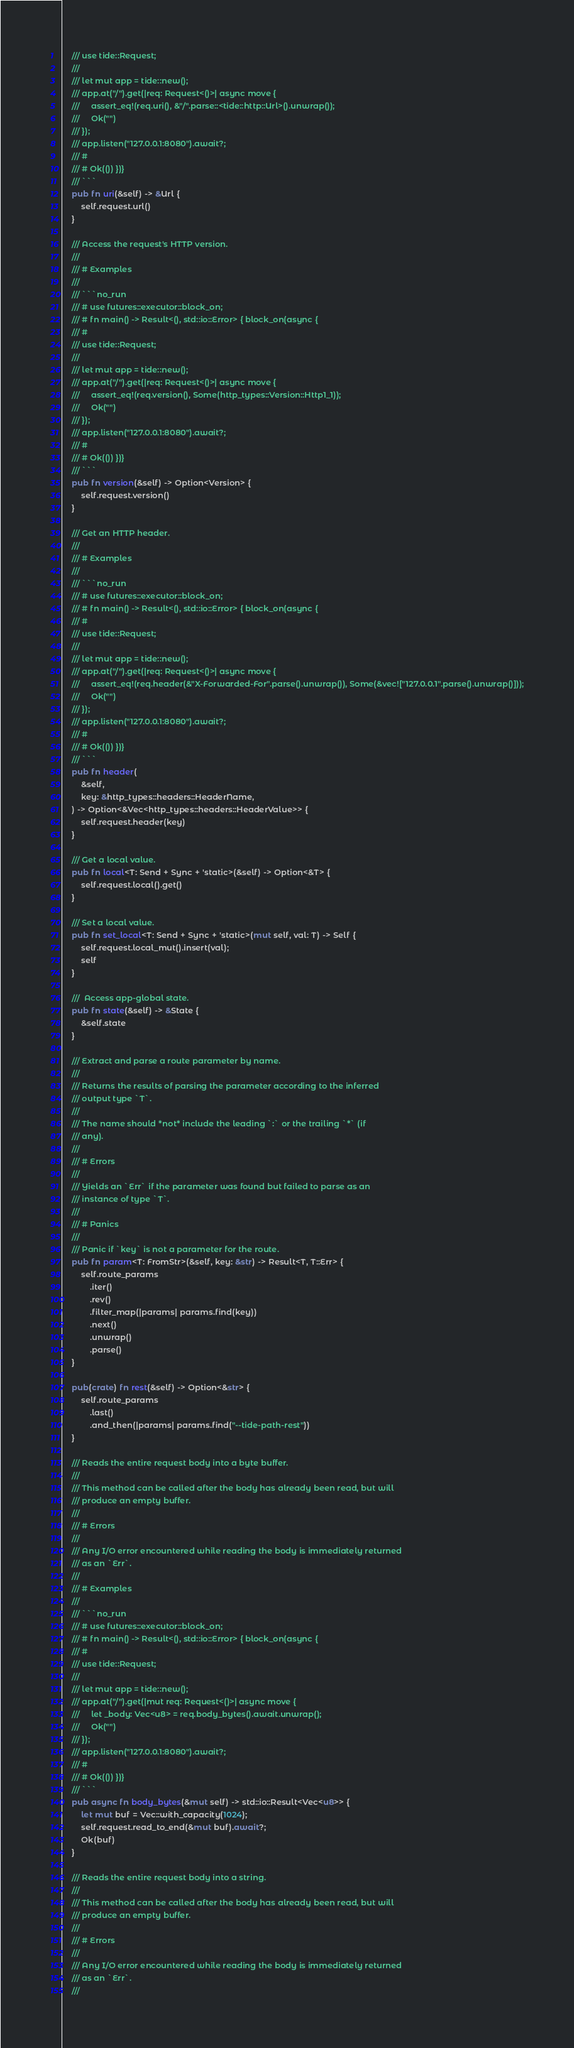Convert code to text. <code><loc_0><loc_0><loc_500><loc_500><_Rust_>    /// use tide::Request;
    ///
    /// let mut app = tide::new();
    /// app.at("/").get(|req: Request<()>| async move {
    ///     assert_eq!(req.uri(), &"/".parse::<tide::http::Url>().unwrap());
    ///     Ok("")
    /// });
    /// app.listen("127.0.0.1:8080").await?;
    /// #
    /// # Ok(()) })}
    /// ```
    pub fn uri(&self) -> &Url {
        self.request.url()
    }

    /// Access the request's HTTP version.
    ///
    /// # Examples
    ///
    /// ```no_run
    /// # use futures::executor::block_on;
    /// # fn main() -> Result<(), std::io::Error> { block_on(async {
    /// #
    /// use tide::Request;
    ///
    /// let mut app = tide::new();
    /// app.at("/").get(|req: Request<()>| async move {
    ///     assert_eq!(req.version(), Some(http_types::Version::Http1_1));
    ///     Ok("")
    /// });
    /// app.listen("127.0.0.1:8080").await?;
    /// #
    /// # Ok(()) })}
    /// ```
    pub fn version(&self) -> Option<Version> {
        self.request.version()
    }

    /// Get an HTTP header.
    ///
    /// # Examples
    ///
    /// ```no_run
    /// # use futures::executor::block_on;
    /// # fn main() -> Result<(), std::io::Error> { block_on(async {
    /// #
    /// use tide::Request;
    ///
    /// let mut app = tide::new();
    /// app.at("/").get(|req: Request<()>| async move {
    ///     assert_eq!(req.header(&"X-Forwarded-For".parse().unwrap()), Some(&vec!["127.0.0.1".parse().unwrap()]));
    ///     Ok("")
    /// });
    /// app.listen("127.0.0.1:8080").await?;
    /// #
    /// # Ok(()) })}
    /// ```
    pub fn header(
        &self,
        key: &http_types::headers::HeaderName,
    ) -> Option<&Vec<http_types::headers::HeaderValue>> {
        self.request.header(key)
    }

    /// Get a local value.
    pub fn local<T: Send + Sync + 'static>(&self) -> Option<&T> {
        self.request.local().get()
    }

    /// Set a local value.
    pub fn set_local<T: Send + Sync + 'static>(mut self, val: T) -> Self {
        self.request.local_mut().insert(val);
        self
    }

    ///  Access app-global state.
    pub fn state(&self) -> &State {
        &self.state
    }

    /// Extract and parse a route parameter by name.
    ///
    /// Returns the results of parsing the parameter according to the inferred
    /// output type `T`.
    ///
    /// The name should *not* include the leading `:` or the trailing `*` (if
    /// any).
    ///
    /// # Errors
    ///
    /// Yields an `Err` if the parameter was found but failed to parse as an
    /// instance of type `T`.
    ///
    /// # Panics
    ///
    /// Panic if `key` is not a parameter for the route.
    pub fn param<T: FromStr>(&self, key: &str) -> Result<T, T::Err> {
        self.route_params
            .iter()
            .rev()
            .filter_map(|params| params.find(key))
            .next()
            .unwrap()
            .parse()
    }

    pub(crate) fn rest(&self) -> Option<&str> {
        self.route_params
            .last()
            .and_then(|params| params.find("--tide-path-rest"))
    }

    /// Reads the entire request body into a byte buffer.
    ///
    /// This method can be called after the body has already been read, but will
    /// produce an empty buffer.
    ///
    /// # Errors
    ///
    /// Any I/O error encountered while reading the body is immediately returned
    /// as an `Err`.
    ///
    /// # Examples
    ///
    /// ```no_run
    /// # use futures::executor::block_on;
    /// # fn main() -> Result<(), std::io::Error> { block_on(async {
    /// #
    /// use tide::Request;
    ///
    /// let mut app = tide::new();
    /// app.at("/").get(|mut req: Request<()>| async move {
    ///     let _body: Vec<u8> = req.body_bytes().await.unwrap();
    ///     Ok("")
    /// });
    /// app.listen("127.0.0.1:8080").await?;
    /// #
    /// # Ok(()) })}
    /// ```
    pub async fn body_bytes(&mut self) -> std::io::Result<Vec<u8>> {
        let mut buf = Vec::with_capacity(1024);
        self.request.read_to_end(&mut buf).await?;
        Ok(buf)
    }

    /// Reads the entire request body into a string.
    ///
    /// This method can be called after the body has already been read, but will
    /// produce an empty buffer.
    ///
    /// # Errors
    ///
    /// Any I/O error encountered while reading the body is immediately returned
    /// as an `Err`.
    ///</code> 